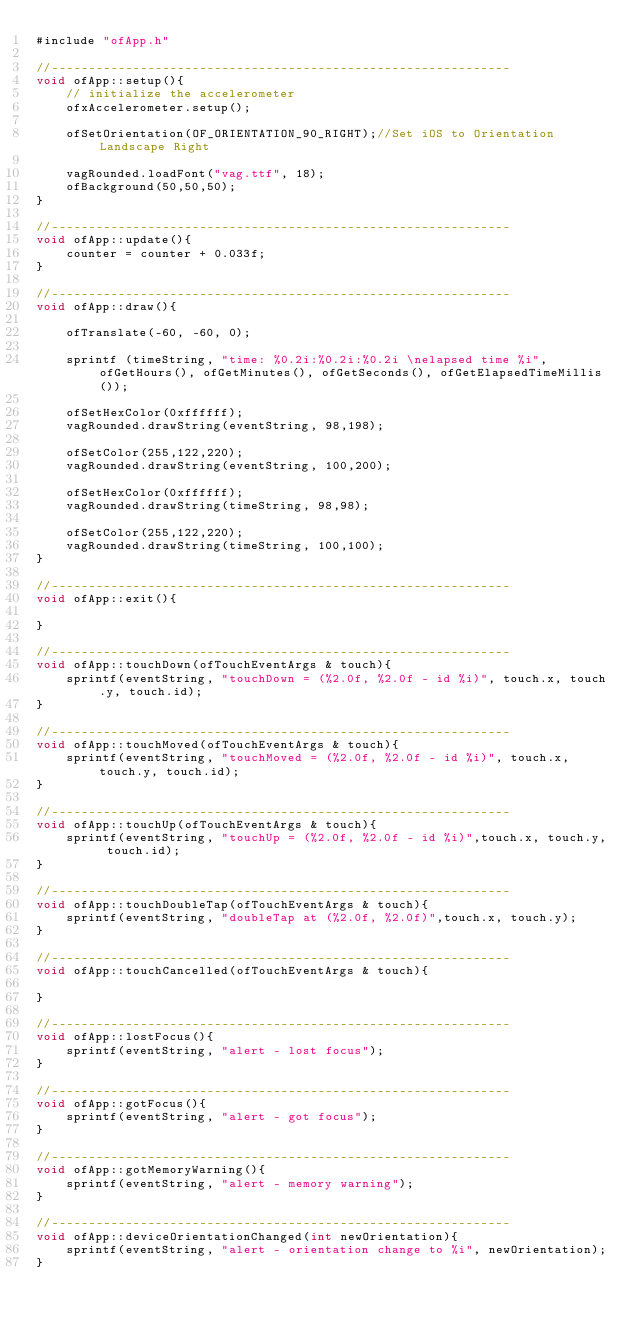<code> <loc_0><loc_0><loc_500><loc_500><_ObjectiveC_>#include "ofApp.h"

//--------------------------------------------------------------
void ofApp::setup(){	
	// initialize the accelerometer
	ofxAccelerometer.setup();
	
	ofSetOrientation(OF_ORIENTATION_90_RIGHT);//Set iOS to Orientation Landscape Right
	
	vagRounded.loadFont("vag.ttf", 18);
	ofBackground(50,50,50);	
}

//--------------------------------------------------------------
void ofApp::update(){
	counter = counter + 0.033f;
}

//--------------------------------------------------------------
void ofApp::draw(){

	ofTranslate(-60, -60, 0);

	sprintf (timeString, "time: %0.2i:%0.2i:%0.2i \nelapsed time %i", ofGetHours(), ofGetMinutes(), ofGetSeconds(), ofGetElapsedTimeMillis());
	
	ofSetHexColor(0xffffff);
	vagRounded.drawString(eventString, 98,198);
	
	ofSetColor(255,122,220);
	vagRounded.drawString(eventString, 100,200);
	
	ofSetHexColor(0xffffff);
	vagRounded.drawString(timeString, 98,98);
	
	ofSetColor(255,122,220);
	vagRounded.drawString(timeString, 100,100);	
}

//--------------------------------------------------------------
void ofApp::exit(){

}

//--------------------------------------------------------------
void ofApp::touchDown(ofTouchEventArgs & touch){
	sprintf(eventString, "touchDown = (%2.0f, %2.0f - id %i)", touch.x, touch.y, touch.id);
}

//--------------------------------------------------------------
void ofApp::touchMoved(ofTouchEventArgs & touch){
	sprintf(eventString, "touchMoved = (%2.0f, %2.0f - id %i)", touch.x, touch.y, touch.id);
}

//--------------------------------------------------------------
void ofApp::touchUp(ofTouchEventArgs & touch){
	sprintf(eventString, "touchUp = (%2.0f, %2.0f - id %i)",touch.x, touch.y, touch.id);
}

//--------------------------------------------------------------
void ofApp::touchDoubleTap(ofTouchEventArgs & touch){
	sprintf(eventString, "doubleTap at (%2.0f, %2.0f)",touch.x, touch.y);
}

//--------------------------------------------------------------
void ofApp::touchCancelled(ofTouchEventArgs & touch){
    
}

//--------------------------------------------------------------
void ofApp::lostFocus(){
	sprintf(eventString, "alert - lost focus");
}

//--------------------------------------------------------------
void ofApp::gotFocus(){
	sprintf(eventString, "alert - got focus");
}

//--------------------------------------------------------------
void ofApp::gotMemoryWarning(){
	sprintf(eventString, "alert - memory warning");
}

//--------------------------------------------------------------
void ofApp::deviceOrientationChanged(int newOrientation){
	sprintf(eventString, "alert - orientation change to %i", newOrientation);
}

</code> 